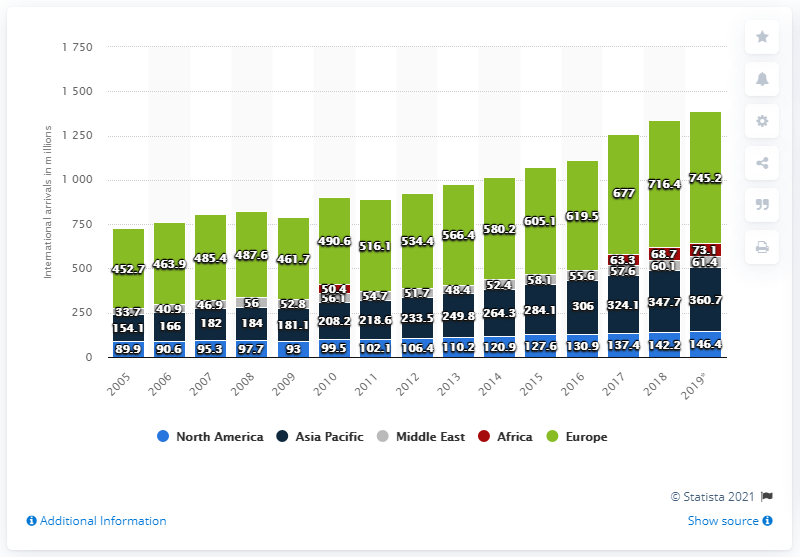Mention a couple of crucial points in this snapshot. In 2019, there were 61.4 million international tourist arrivals in the Middle East. In 2019, there were 146.4 million international tourist arrivals in North America. 